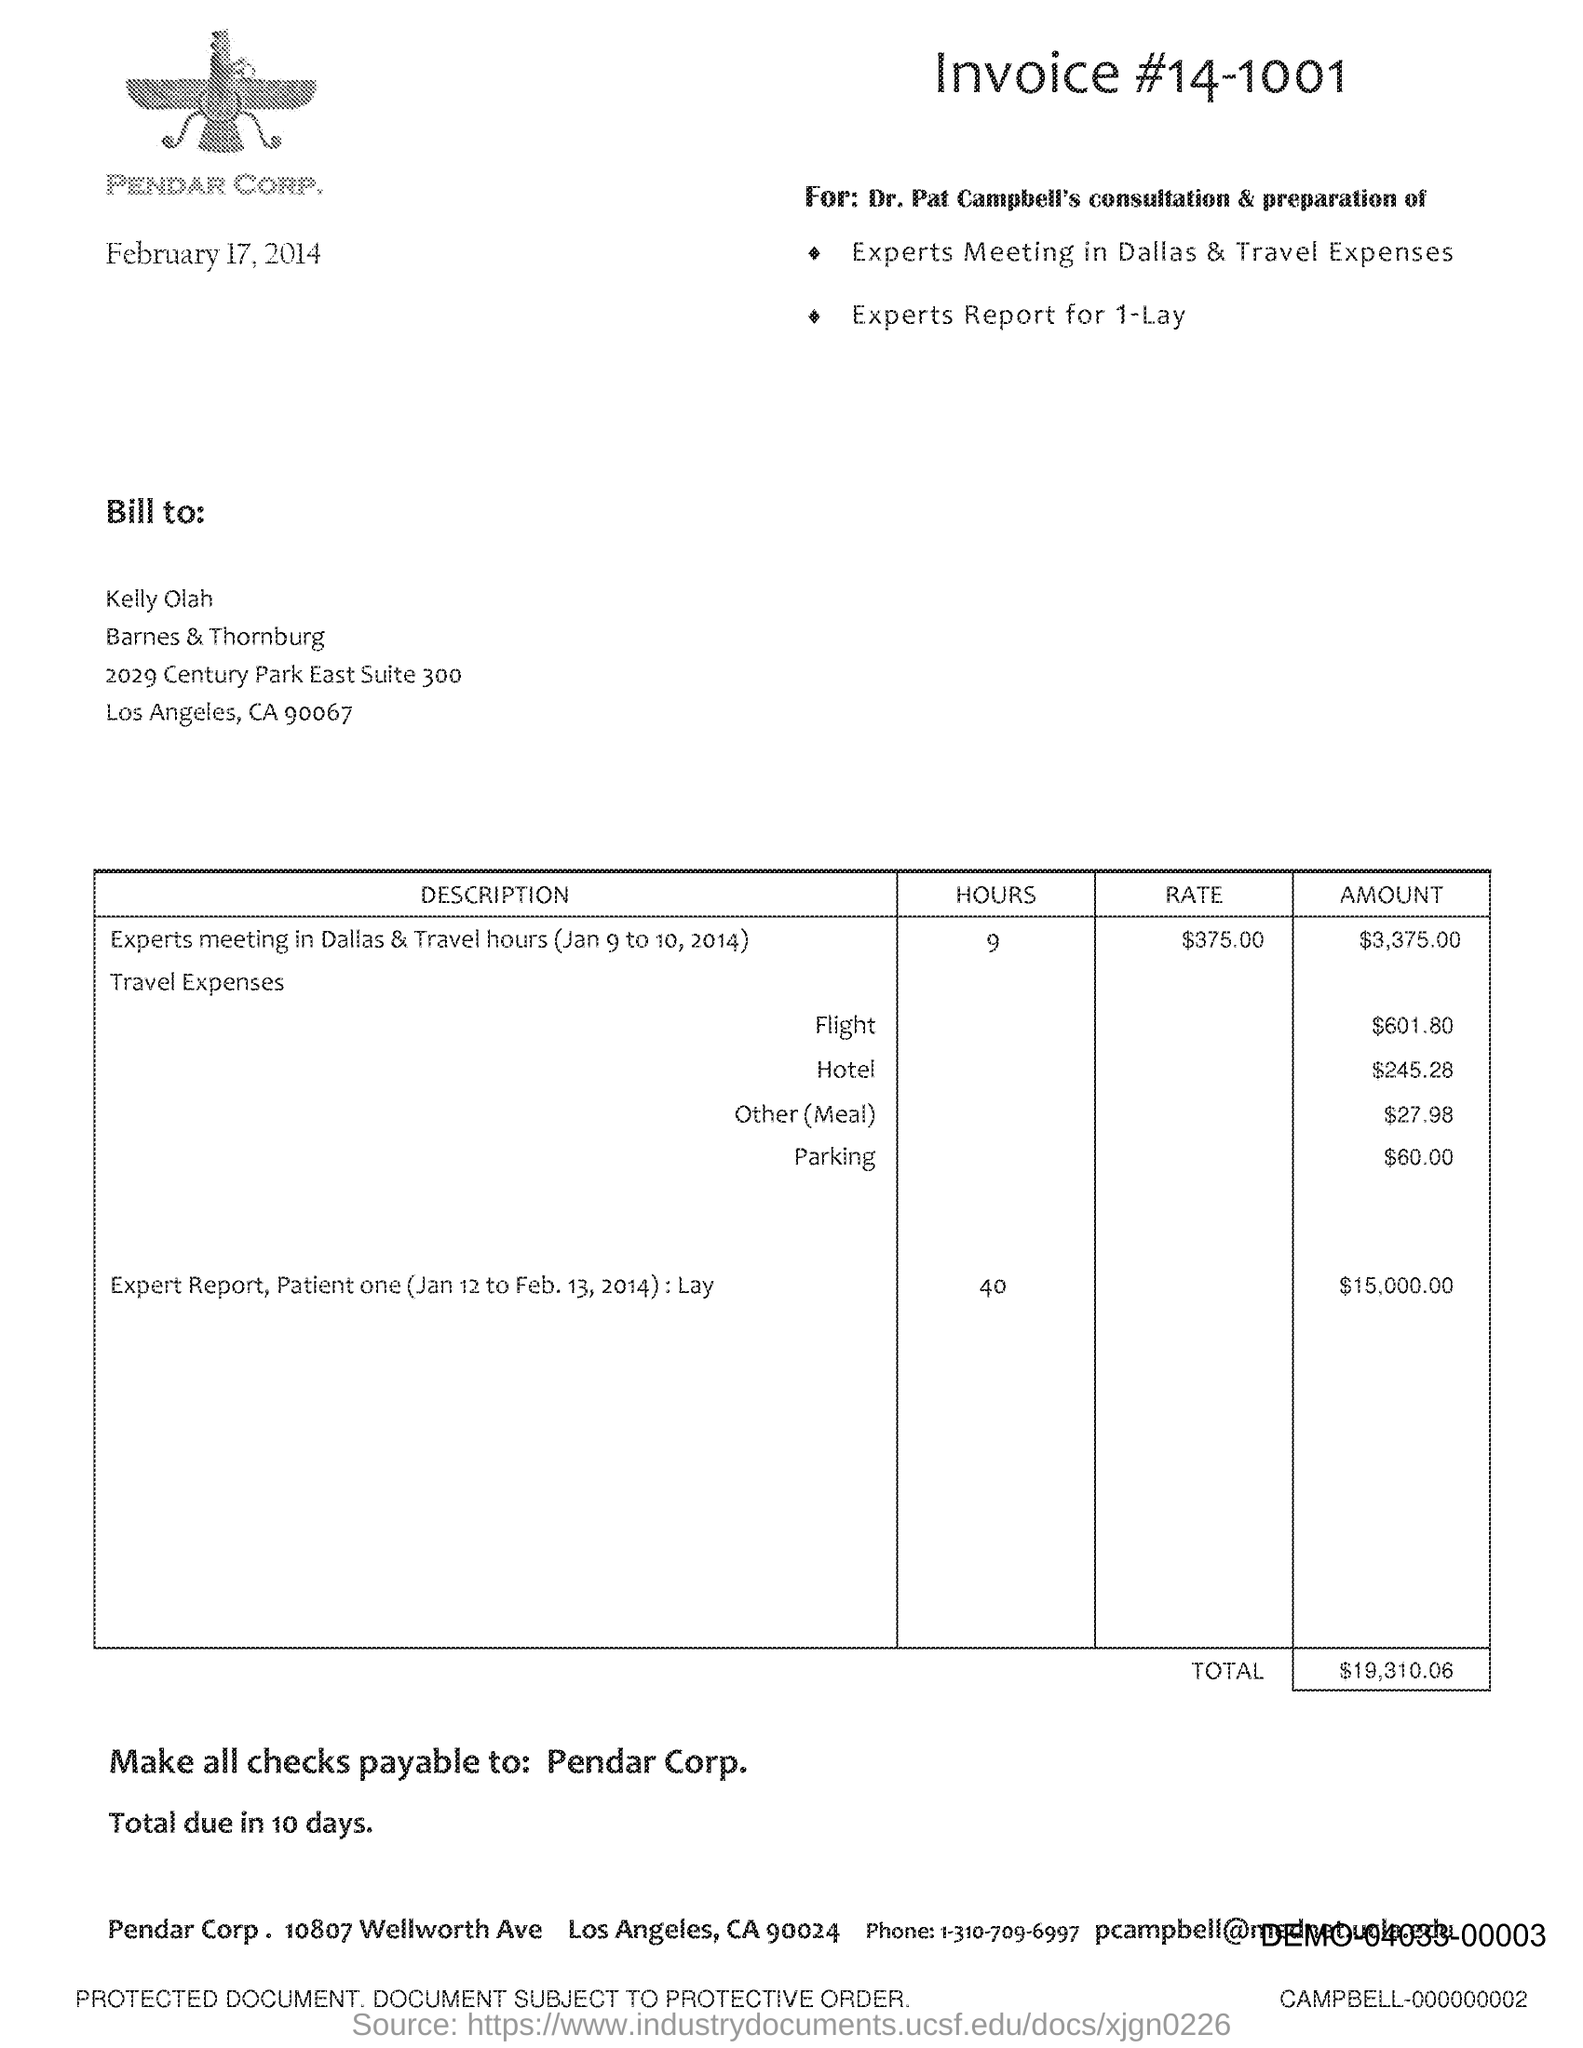Draw attention to some important aspects in this diagram. The numerical sequence '14-1001' represents an invoice. Pendar Corp. is located in the state of California. The address of Pendar Corp is 10807 Wellworth Ave. The total is $19,310.06. 